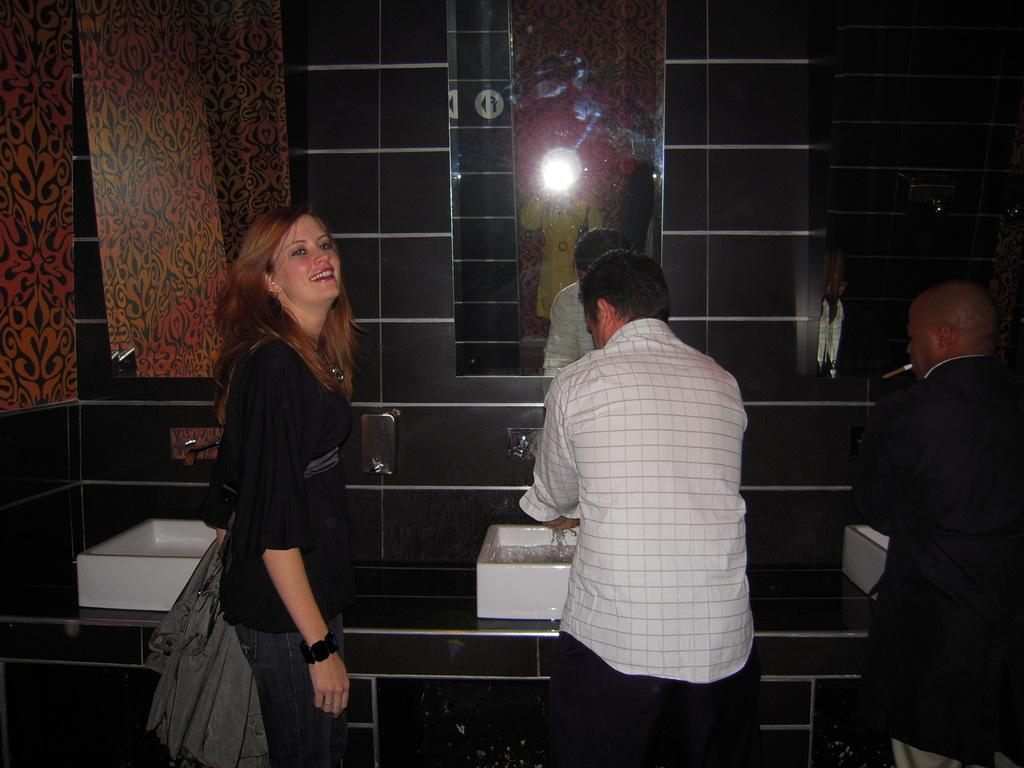How many people are present in the image? There are three people in the image: two men and a woman. What objects can be seen on a platform in the image? There are wash basins on a platform in the image. What can be seen in the background of the image? There is a wall and mirrors in the background of the image. How many geese are visible on the hill in the image? There is no hill or geese present in the image. What type of parcel is being delivered to the woman in the image? There is no parcel or delivery being depicted in the image. 